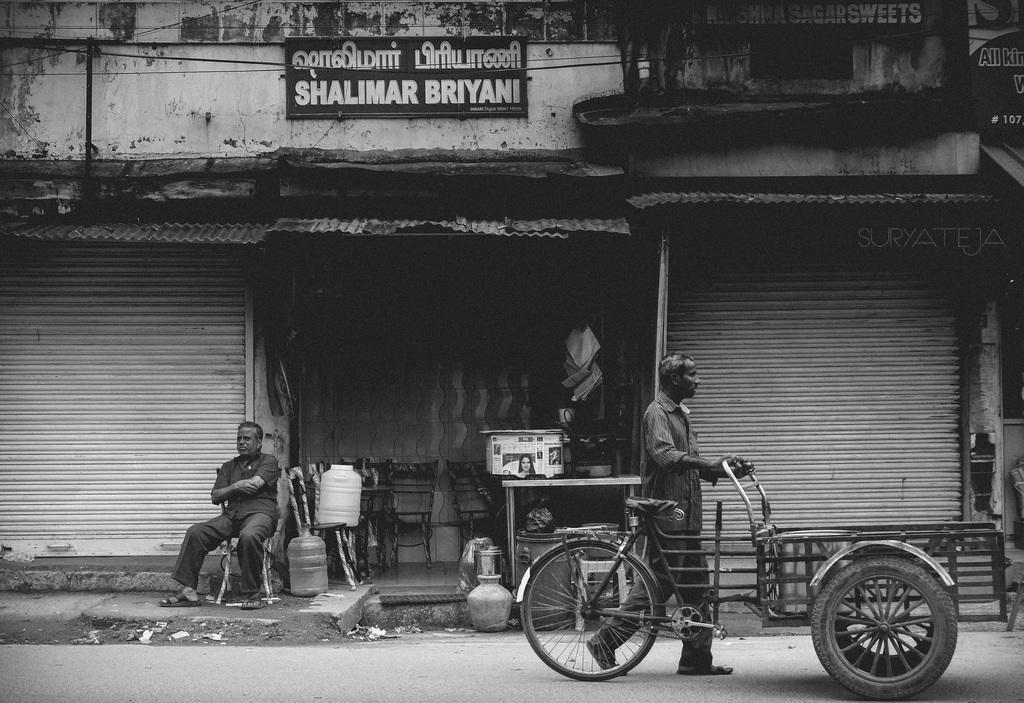Please provide a concise description of this image. In the picture we can see a three shops with shutters and middle we can see one shop is opened in it, we can see some chairs, table and some things are placed on it and outside of the shop we can see a man sitting on the chair and on the top of the shop we can see a board name on it as Shalimar biryani, and near to the shop we can see a man walking and holding a cycle cart. 